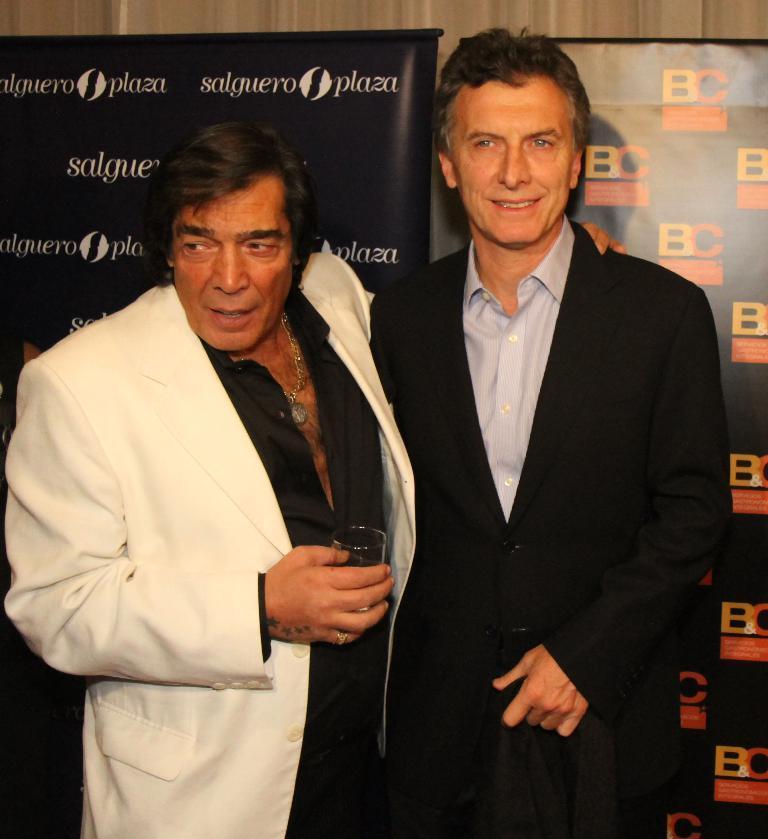How would you summarize this image in a sentence or two? In the picture I can see two men. They are wearing a suit. I can see a man on the right side is smiling. There is a man on the left side is holding a glass in his right hand. In the background, I can see the hoardings. 